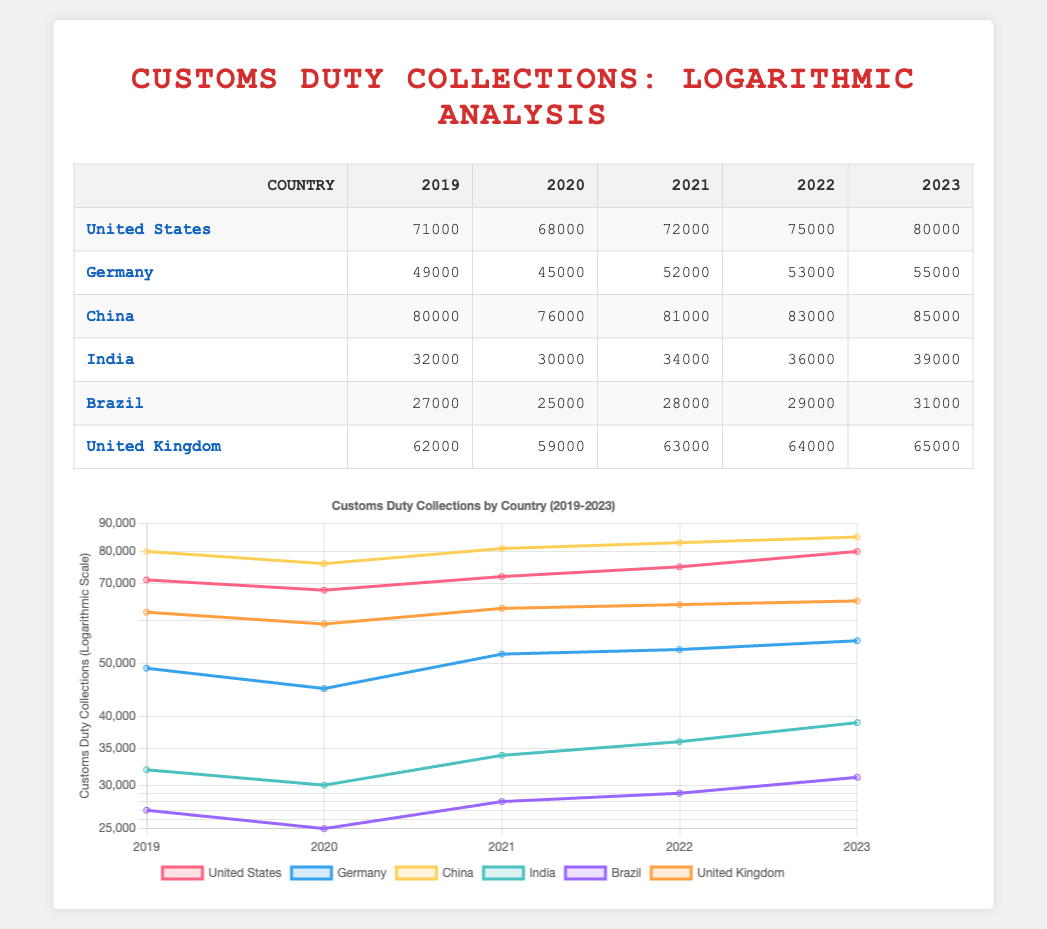What was the customs duty collection of Germany in 2021? The table shows that the customs duty collection for Germany in 2021 is listed under the corresponding year column, which shows the value to be 52,000.
Answer: 52,000 Which country had the highest customs duty collection in 2023? In the 2023 column, comparing the values across all countries, China has the highest collection at 85,000, higher than any other country's reported figure for that year.
Answer: China What is the percentage increase in customs duty collections for India from 2019 to 2023? First, find the 2019 and 2023 collections for India, which are 32,000 and 39,000 respectively. The increase is 39,000 - 32,000 = 7,000. To find the percentage increase: (7,000 / 32,000) * 100 = 21.875%.
Answer: 21.875% Did the United Kingdom's customs duty collections decrease at any point between 2019 and 2023? By examining the collections from 2019 to 2023, it can be seen that the collections decreased from 62,000 in 2019 to 59,000 in 2020, confirming that a decrease occurred during this period.
Answer: Yes What is the total customs duty collection for all countries in 2022? To find the total for 2022, sum the collections: United States (75,000) + Germany (53,000) + China (83,000) + India (36,000) + Brazil (29,000) + United Kingdom (64,000) = 75,000 + 53,000 + 83,000 + 36,000 + 29,000 + 64,000 = 340,000.
Answer: 340,000 Which country had the lowest customs duty collection in 2020? The 2020 values show that Brazil (25,000) has the lowest collection compared to others, making it the lowest for that year.
Answer: Brazil What was the difference in customs duty collections for the United States between 2019 and 2022? For the United States, the collection in 2019 is 71,000 and in 2022 it is 75,000. The difference is calculated as 75,000 - 71,000 = 4,000.
Answer: 4,000 Which country experienced the highest growth in customs duty collections from 2019 to 2023? Analyze the growth from 2019 to 2023: US (8,000), Germany (6,000), China (5,000), India (7,000), Brazil (4,000), and UK (3,000). The highest growth is seen in the US with 8,000.
Answer: United States 